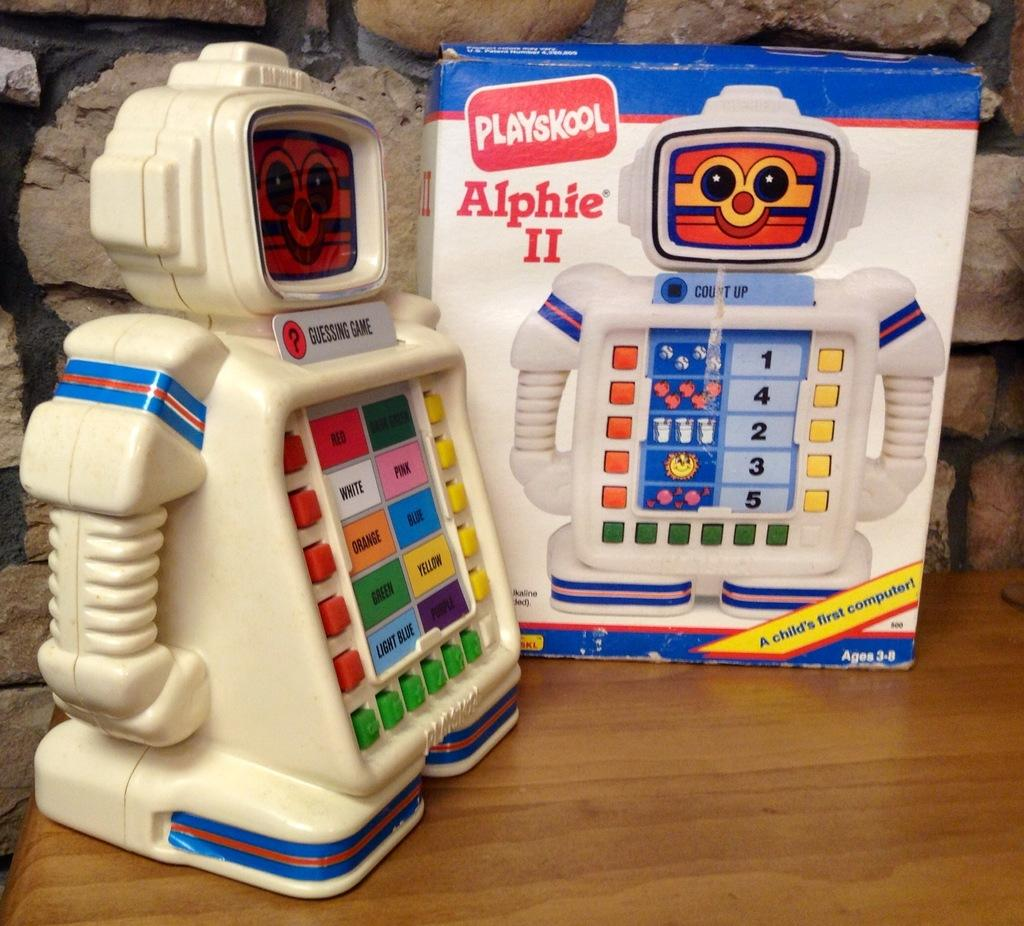What is the main subject of the image? The main subject of the image is a toy robot. How is the toy robot represented in the image? The toy robot is printed on a box. Where is the toy robot placed in the image? The toy robot is placed on a surface. What is the box containing the toy robot placed on? The box is placed on a surface. What can be seen behind the box in the image? There is a wall behind the box. What type of cheese is being sliced on the wall in the image? There is no cheese or slicing activity present in the image; it features a toy robot on a box with a wall in the background. 